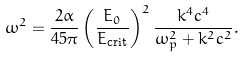Convert formula to latex. <formula><loc_0><loc_0><loc_500><loc_500>\omega ^ { 2 } = \frac { 2 \alpha } { 4 5 \pi } \left ( \frac { E _ { 0 } } { E _ { \text {crit} } } \right ) ^ { 2 } \frac { k ^ { 4 } c ^ { 4 } } { \omega _ { p } ^ { 2 } + k ^ { 2 } c ^ { 2 } } .</formula> 